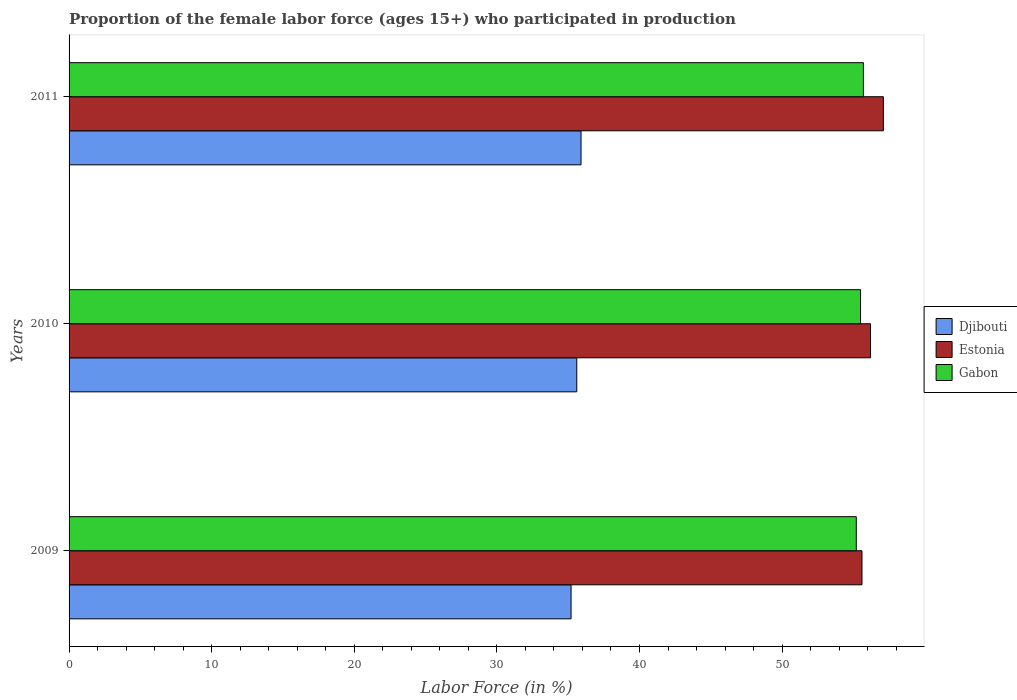Are the number of bars on each tick of the Y-axis equal?
Provide a short and direct response. Yes. In how many cases, is the number of bars for a given year not equal to the number of legend labels?
Your response must be concise. 0. What is the proportion of the female labor force who participated in production in Djibouti in 2011?
Provide a short and direct response. 35.9. Across all years, what is the maximum proportion of the female labor force who participated in production in Djibouti?
Your response must be concise. 35.9. Across all years, what is the minimum proportion of the female labor force who participated in production in Djibouti?
Provide a succinct answer. 35.2. In which year was the proportion of the female labor force who participated in production in Estonia maximum?
Ensure brevity in your answer.  2011. What is the total proportion of the female labor force who participated in production in Estonia in the graph?
Make the answer very short. 168.9. What is the difference between the proportion of the female labor force who participated in production in Gabon in 2010 and the proportion of the female labor force who participated in production in Djibouti in 2009?
Provide a succinct answer. 20.3. What is the average proportion of the female labor force who participated in production in Djibouti per year?
Provide a short and direct response. 35.57. In the year 2010, what is the difference between the proportion of the female labor force who participated in production in Estonia and proportion of the female labor force who participated in production in Djibouti?
Provide a succinct answer. 20.6. What is the ratio of the proportion of the female labor force who participated in production in Djibouti in 2009 to that in 2011?
Provide a short and direct response. 0.98. What is the difference between the highest and the second highest proportion of the female labor force who participated in production in Gabon?
Make the answer very short. 0.2. What is the difference between the highest and the lowest proportion of the female labor force who participated in production in Djibouti?
Ensure brevity in your answer.  0.7. Is the sum of the proportion of the female labor force who participated in production in Gabon in 2009 and 2010 greater than the maximum proportion of the female labor force who participated in production in Djibouti across all years?
Ensure brevity in your answer.  Yes. What does the 3rd bar from the top in 2009 represents?
Make the answer very short. Djibouti. What does the 3rd bar from the bottom in 2009 represents?
Give a very brief answer. Gabon. How many bars are there?
Your response must be concise. 9. Are all the bars in the graph horizontal?
Keep it short and to the point. Yes. What is the difference between two consecutive major ticks on the X-axis?
Ensure brevity in your answer.  10. Are the values on the major ticks of X-axis written in scientific E-notation?
Your response must be concise. No. Does the graph contain any zero values?
Your answer should be very brief. No. Where does the legend appear in the graph?
Make the answer very short. Center right. How are the legend labels stacked?
Offer a terse response. Vertical. What is the title of the graph?
Provide a succinct answer. Proportion of the female labor force (ages 15+) who participated in production. What is the Labor Force (in %) of Djibouti in 2009?
Make the answer very short. 35.2. What is the Labor Force (in %) in Estonia in 2009?
Make the answer very short. 55.6. What is the Labor Force (in %) in Gabon in 2009?
Provide a short and direct response. 55.2. What is the Labor Force (in %) of Djibouti in 2010?
Provide a short and direct response. 35.6. What is the Labor Force (in %) of Estonia in 2010?
Give a very brief answer. 56.2. What is the Labor Force (in %) in Gabon in 2010?
Keep it short and to the point. 55.5. What is the Labor Force (in %) of Djibouti in 2011?
Your response must be concise. 35.9. What is the Labor Force (in %) in Estonia in 2011?
Make the answer very short. 57.1. What is the Labor Force (in %) in Gabon in 2011?
Give a very brief answer. 55.7. Across all years, what is the maximum Labor Force (in %) of Djibouti?
Make the answer very short. 35.9. Across all years, what is the maximum Labor Force (in %) of Estonia?
Make the answer very short. 57.1. Across all years, what is the maximum Labor Force (in %) of Gabon?
Keep it short and to the point. 55.7. Across all years, what is the minimum Labor Force (in %) in Djibouti?
Your response must be concise. 35.2. Across all years, what is the minimum Labor Force (in %) in Estonia?
Keep it short and to the point. 55.6. Across all years, what is the minimum Labor Force (in %) of Gabon?
Offer a terse response. 55.2. What is the total Labor Force (in %) of Djibouti in the graph?
Offer a very short reply. 106.7. What is the total Labor Force (in %) of Estonia in the graph?
Keep it short and to the point. 168.9. What is the total Labor Force (in %) of Gabon in the graph?
Provide a short and direct response. 166.4. What is the difference between the Labor Force (in %) of Djibouti in 2009 and that in 2010?
Ensure brevity in your answer.  -0.4. What is the difference between the Labor Force (in %) of Estonia in 2009 and that in 2010?
Provide a succinct answer. -0.6. What is the difference between the Labor Force (in %) of Gabon in 2009 and that in 2010?
Provide a succinct answer. -0.3. What is the difference between the Labor Force (in %) of Djibouti in 2009 and that in 2011?
Ensure brevity in your answer.  -0.7. What is the difference between the Labor Force (in %) of Estonia in 2009 and that in 2011?
Keep it short and to the point. -1.5. What is the difference between the Labor Force (in %) in Gabon in 2009 and that in 2011?
Give a very brief answer. -0.5. What is the difference between the Labor Force (in %) of Estonia in 2010 and that in 2011?
Make the answer very short. -0.9. What is the difference between the Labor Force (in %) of Djibouti in 2009 and the Labor Force (in %) of Estonia in 2010?
Offer a terse response. -21. What is the difference between the Labor Force (in %) of Djibouti in 2009 and the Labor Force (in %) of Gabon in 2010?
Give a very brief answer. -20.3. What is the difference between the Labor Force (in %) of Djibouti in 2009 and the Labor Force (in %) of Estonia in 2011?
Your response must be concise. -21.9. What is the difference between the Labor Force (in %) in Djibouti in 2009 and the Labor Force (in %) in Gabon in 2011?
Keep it short and to the point. -20.5. What is the difference between the Labor Force (in %) of Djibouti in 2010 and the Labor Force (in %) of Estonia in 2011?
Give a very brief answer. -21.5. What is the difference between the Labor Force (in %) in Djibouti in 2010 and the Labor Force (in %) in Gabon in 2011?
Ensure brevity in your answer.  -20.1. What is the average Labor Force (in %) of Djibouti per year?
Your answer should be very brief. 35.57. What is the average Labor Force (in %) in Estonia per year?
Offer a very short reply. 56.3. What is the average Labor Force (in %) in Gabon per year?
Make the answer very short. 55.47. In the year 2009, what is the difference between the Labor Force (in %) in Djibouti and Labor Force (in %) in Estonia?
Keep it short and to the point. -20.4. In the year 2009, what is the difference between the Labor Force (in %) of Djibouti and Labor Force (in %) of Gabon?
Keep it short and to the point. -20. In the year 2009, what is the difference between the Labor Force (in %) in Estonia and Labor Force (in %) in Gabon?
Keep it short and to the point. 0.4. In the year 2010, what is the difference between the Labor Force (in %) of Djibouti and Labor Force (in %) of Estonia?
Your response must be concise. -20.6. In the year 2010, what is the difference between the Labor Force (in %) in Djibouti and Labor Force (in %) in Gabon?
Provide a succinct answer. -19.9. In the year 2011, what is the difference between the Labor Force (in %) of Djibouti and Labor Force (in %) of Estonia?
Provide a succinct answer. -21.2. In the year 2011, what is the difference between the Labor Force (in %) in Djibouti and Labor Force (in %) in Gabon?
Keep it short and to the point. -19.8. What is the ratio of the Labor Force (in %) in Estonia in 2009 to that in 2010?
Your answer should be compact. 0.99. What is the ratio of the Labor Force (in %) of Djibouti in 2009 to that in 2011?
Keep it short and to the point. 0.98. What is the ratio of the Labor Force (in %) in Estonia in 2009 to that in 2011?
Your answer should be very brief. 0.97. What is the ratio of the Labor Force (in %) in Djibouti in 2010 to that in 2011?
Your response must be concise. 0.99. What is the ratio of the Labor Force (in %) in Estonia in 2010 to that in 2011?
Your response must be concise. 0.98. What is the difference between the highest and the second highest Labor Force (in %) of Gabon?
Your answer should be compact. 0.2. What is the difference between the highest and the lowest Labor Force (in %) in Estonia?
Make the answer very short. 1.5. What is the difference between the highest and the lowest Labor Force (in %) of Gabon?
Provide a succinct answer. 0.5. 